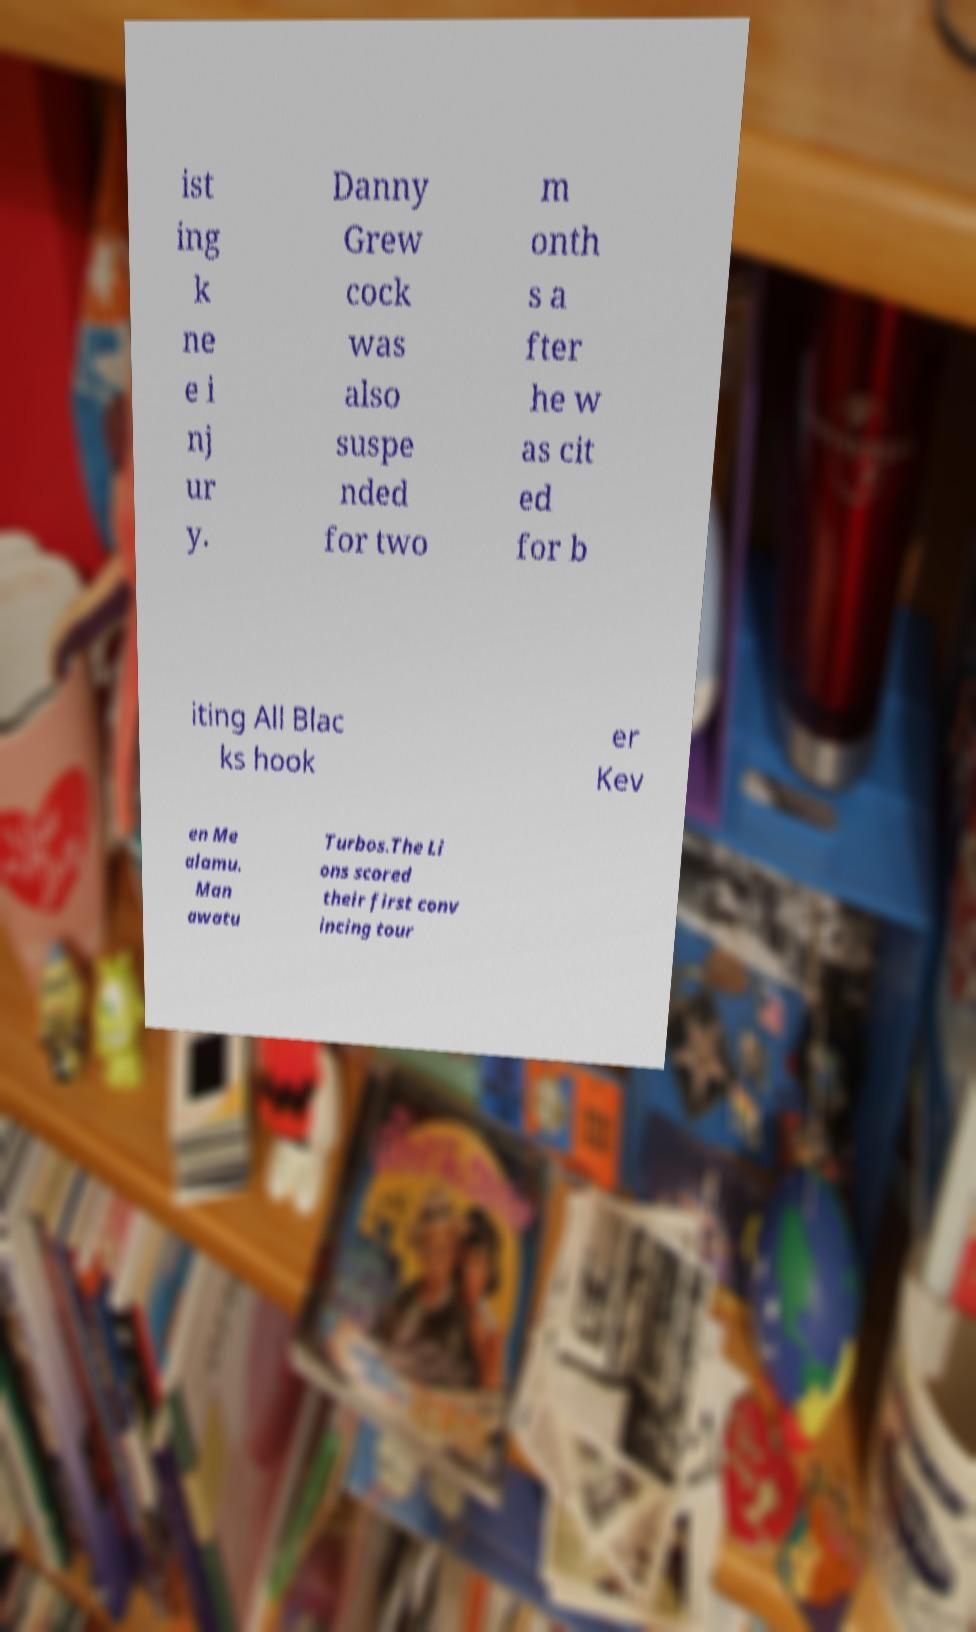For documentation purposes, I need the text within this image transcribed. Could you provide that? ist ing k ne e i nj ur y. Danny Grew cock was also suspe nded for two m onth s a fter he w as cit ed for b iting All Blac ks hook er Kev en Me alamu. Man awatu Turbos.The Li ons scored their first conv incing tour 